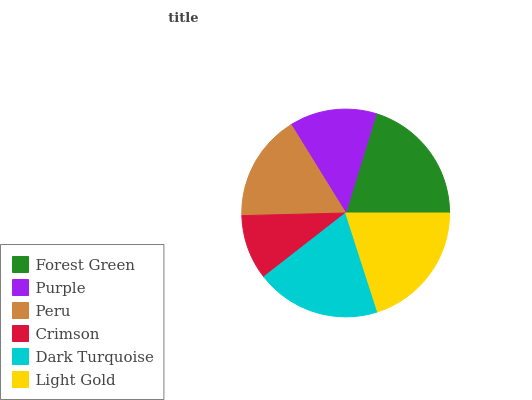Is Crimson the minimum?
Answer yes or no. Yes. Is Forest Green the maximum?
Answer yes or no. Yes. Is Purple the minimum?
Answer yes or no. No. Is Purple the maximum?
Answer yes or no. No. Is Forest Green greater than Purple?
Answer yes or no. Yes. Is Purple less than Forest Green?
Answer yes or no. Yes. Is Purple greater than Forest Green?
Answer yes or no. No. Is Forest Green less than Purple?
Answer yes or no. No. Is Dark Turquoise the high median?
Answer yes or no. Yes. Is Peru the low median?
Answer yes or no. Yes. Is Purple the high median?
Answer yes or no. No. Is Light Gold the low median?
Answer yes or no. No. 